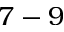<formula> <loc_0><loc_0><loc_500><loc_500>7 - 9</formula> 